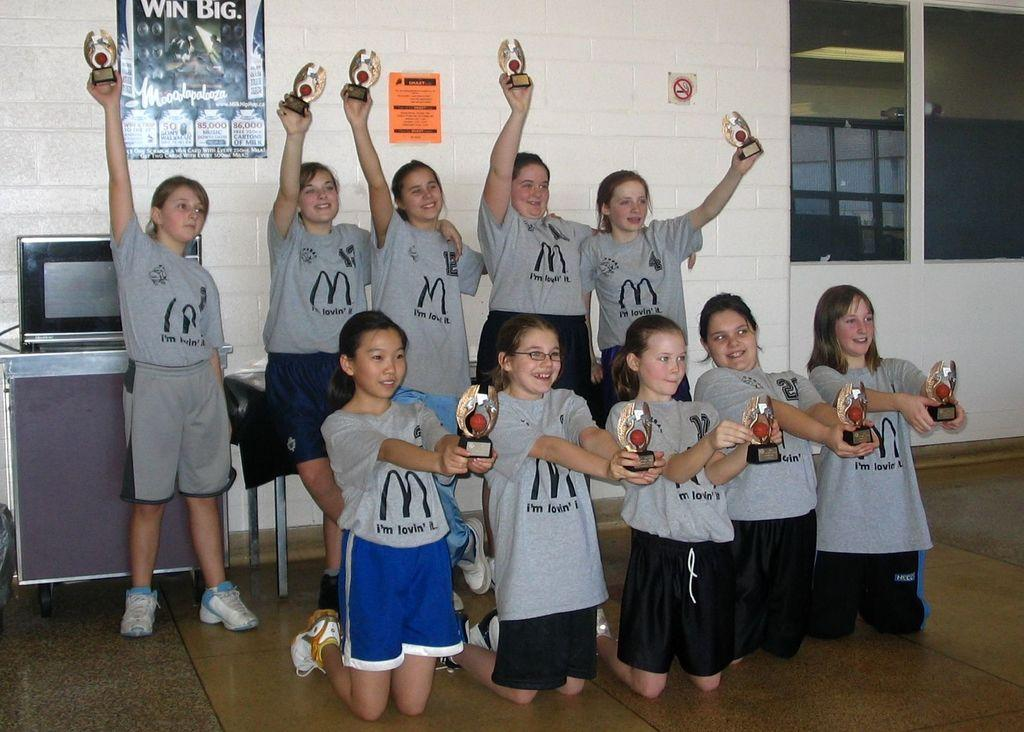<image>
Offer a succinct explanation of the picture presented. A group of kids with grey shirts that say I'm Lovin' It holding up trophies. 